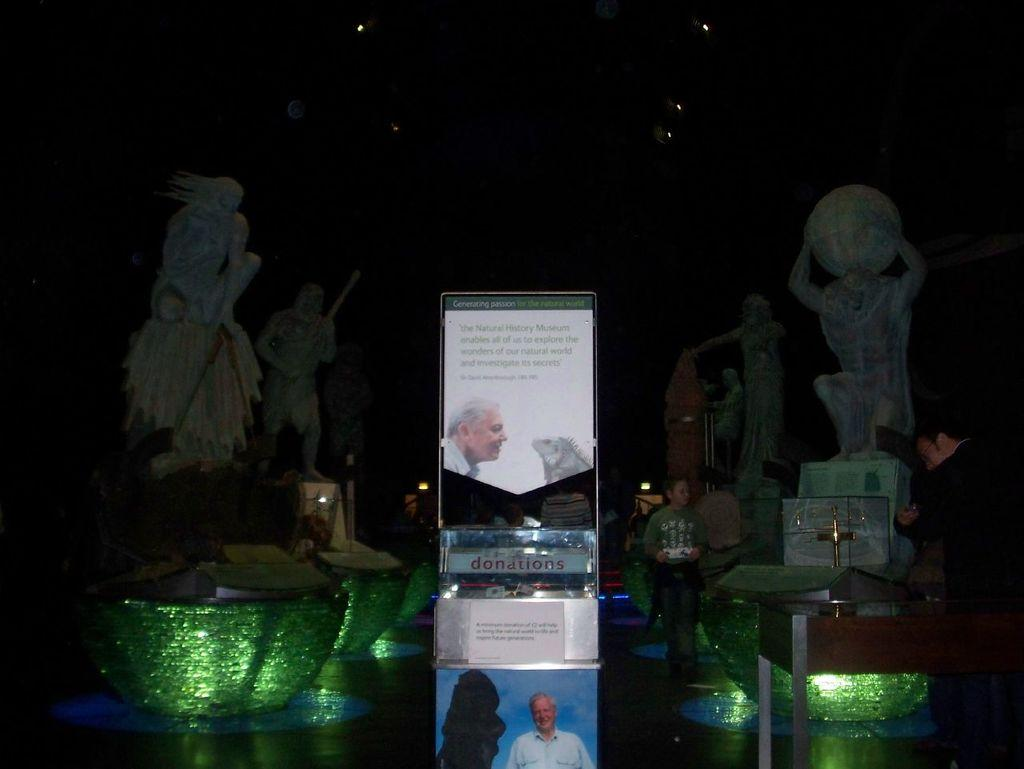What type of objects can be seen in the image? There are statues, boards, a poster, and other objects in the image. What is the purpose of the boards and poster? Something is written on the boards and poster, which suggests they are used for displaying information or messages. Can you describe the people in the image? There are people present in the image, but their specific actions or appearances are not mentioned in the provided facts. What type of lighting is visible in the image? There are lights in the image, which could provide illumination or serve a decorative purpose. What type of lunchroom can be seen in the image? There is no mention of a lunchroom in the provided facts, so it cannot be determined if one is present in the image. How does the ice affect the statues in the image? There is no mention of ice in the provided facts, so it cannot be determined if it affects the statues in the image. 